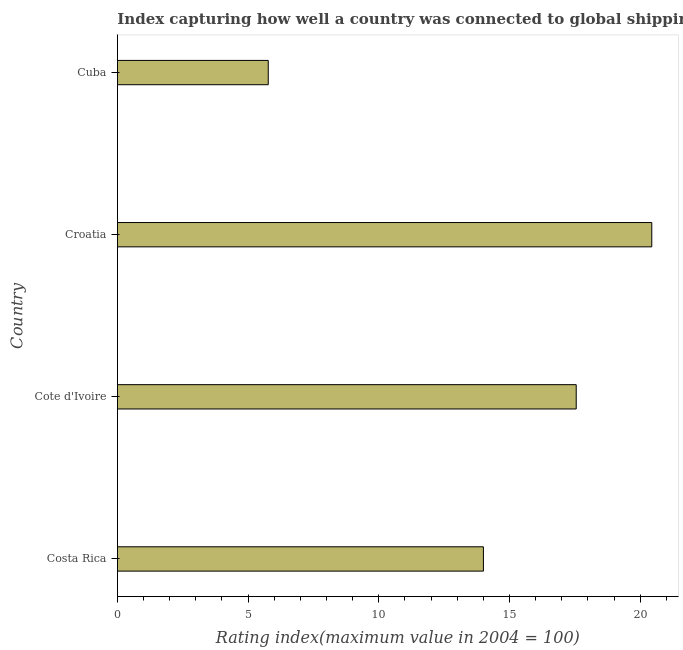Does the graph contain any zero values?
Ensure brevity in your answer.  No. Does the graph contain grids?
Your response must be concise. No. What is the title of the graph?
Your response must be concise. Index capturing how well a country was connected to global shipping networks in 2013. What is the label or title of the X-axis?
Keep it short and to the point. Rating index(maximum value in 2004 = 100). What is the label or title of the Y-axis?
Your response must be concise. Country. What is the liner shipping connectivity index in Cote d'Ivoire?
Ensure brevity in your answer.  17.55. Across all countries, what is the maximum liner shipping connectivity index?
Your answer should be very brief. 20.44. Across all countries, what is the minimum liner shipping connectivity index?
Your answer should be very brief. 5.77. In which country was the liner shipping connectivity index maximum?
Ensure brevity in your answer.  Croatia. In which country was the liner shipping connectivity index minimum?
Offer a very short reply. Cuba. What is the sum of the liner shipping connectivity index?
Your answer should be very brief. 57.76. What is the difference between the liner shipping connectivity index in Costa Rica and Cuba?
Offer a terse response. 8.23. What is the average liner shipping connectivity index per country?
Your response must be concise. 14.44. What is the median liner shipping connectivity index?
Keep it short and to the point. 15.78. In how many countries, is the liner shipping connectivity index greater than 18 ?
Your answer should be very brief. 1. What is the ratio of the liner shipping connectivity index in Costa Rica to that in Croatia?
Provide a succinct answer. 0.69. Is the difference between the liner shipping connectivity index in Cote d'Ivoire and Croatia greater than the difference between any two countries?
Keep it short and to the point. No. What is the difference between the highest and the second highest liner shipping connectivity index?
Keep it short and to the point. 2.89. What is the difference between the highest and the lowest liner shipping connectivity index?
Offer a terse response. 14.67. How many bars are there?
Offer a very short reply. 4. How many countries are there in the graph?
Give a very brief answer. 4. What is the difference between two consecutive major ticks on the X-axis?
Give a very brief answer. 5. Are the values on the major ticks of X-axis written in scientific E-notation?
Make the answer very short. No. What is the Rating index(maximum value in 2004 = 100) in Costa Rica?
Give a very brief answer. 14. What is the Rating index(maximum value in 2004 = 100) of Cote d'Ivoire?
Offer a very short reply. 17.55. What is the Rating index(maximum value in 2004 = 100) in Croatia?
Give a very brief answer. 20.44. What is the Rating index(maximum value in 2004 = 100) in Cuba?
Ensure brevity in your answer.  5.77. What is the difference between the Rating index(maximum value in 2004 = 100) in Costa Rica and Cote d'Ivoire?
Offer a very short reply. -3.55. What is the difference between the Rating index(maximum value in 2004 = 100) in Costa Rica and Croatia?
Make the answer very short. -6.44. What is the difference between the Rating index(maximum value in 2004 = 100) in Costa Rica and Cuba?
Keep it short and to the point. 8.23. What is the difference between the Rating index(maximum value in 2004 = 100) in Cote d'Ivoire and Croatia?
Your answer should be compact. -2.89. What is the difference between the Rating index(maximum value in 2004 = 100) in Cote d'Ivoire and Cuba?
Offer a terse response. 11.78. What is the difference between the Rating index(maximum value in 2004 = 100) in Croatia and Cuba?
Your response must be concise. 14.67. What is the ratio of the Rating index(maximum value in 2004 = 100) in Costa Rica to that in Cote d'Ivoire?
Your answer should be very brief. 0.8. What is the ratio of the Rating index(maximum value in 2004 = 100) in Costa Rica to that in Croatia?
Your response must be concise. 0.69. What is the ratio of the Rating index(maximum value in 2004 = 100) in Costa Rica to that in Cuba?
Ensure brevity in your answer.  2.43. What is the ratio of the Rating index(maximum value in 2004 = 100) in Cote d'Ivoire to that in Croatia?
Your answer should be compact. 0.86. What is the ratio of the Rating index(maximum value in 2004 = 100) in Cote d'Ivoire to that in Cuba?
Your answer should be very brief. 3.04. What is the ratio of the Rating index(maximum value in 2004 = 100) in Croatia to that in Cuba?
Offer a terse response. 3.54. 